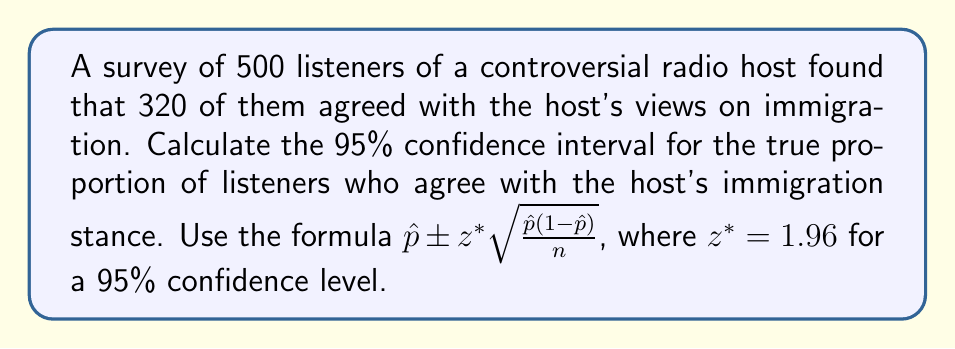Show me your answer to this math problem. 1. Calculate the sample proportion $\hat{p}$:
   $\hat{p} = \frac{320}{500} = 0.64$

2. Calculate $1-\hat{p}$:
   $1-\hat{p} = 1 - 0.64 = 0.36$

3. Determine the sample size $n$:
   $n = 500$

4. Calculate the standard error:
   $SE = \sqrt{\frac{\hat{p}(1-\hat{p})}{n}} = \sqrt{\frac{0.64 \cdot 0.36}{500}} = 0.0214$

5. Multiply the standard error by $z^*$ (1.96 for 95% confidence):
   $1.96 \cdot 0.0214 = 0.0419$

6. Calculate the confidence interval:
   Lower bound: $0.64 - 0.0419 = 0.5981$
   Upper bound: $0.64 + 0.0419 = 0.6819$

7. Convert to percentages:
   59.81% to 68.19%
Answer: 59.81% to 68.19% 